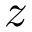<formula> <loc_0><loc_0><loc_500><loc_500>z</formula> 